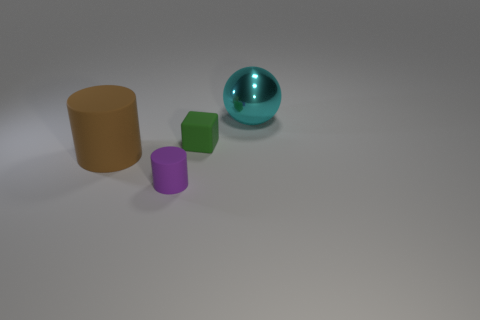There is a large thing to the left of the cyan object; is its color the same as the rubber thing in front of the big matte object?
Give a very brief answer. No. Are there any big brown things made of the same material as the brown cylinder?
Provide a short and direct response. No. How big is the purple rubber object that is in front of the small object behind the brown rubber cylinder?
Provide a short and direct response. Small. Is the number of metal things greater than the number of small rubber things?
Provide a succinct answer. No. Do the brown matte cylinder in front of the green rubber cube and the purple matte thing have the same size?
Ensure brevity in your answer.  No. Is the shape of the big brown matte thing the same as the purple thing?
Ensure brevity in your answer.  Yes. There is a purple object that is the same shape as the brown matte object; what is its size?
Make the answer very short. Small. Are there more large objects that are right of the small purple cylinder than small green matte things on the left side of the green block?
Provide a succinct answer. Yes. Is the green cube made of the same material as the large thing behind the brown thing?
Offer a terse response. No. Is there anything else that has the same shape as the tiny green object?
Provide a short and direct response. No. 